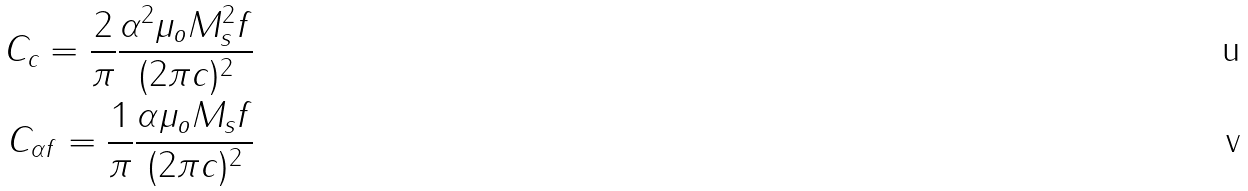Convert formula to latex. <formula><loc_0><loc_0><loc_500><loc_500>C _ { c } = \frac { 2 } { \pi } \frac { \alpha ^ { 2 } \mu _ { o } M ^ { 2 } _ { s } f } { ( 2 \pi c ) ^ { 2 } } \\ C _ { \alpha f } = \frac { 1 } { \pi } \frac { \alpha \mu _ { o } M _ { s } f } { ( 2 \pi c ) ^ { 2 } }</formula> 